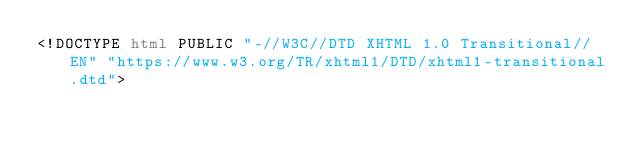Convert code to text. <code><loc_0><loc_0><loc_500><loc_500><_HTML_><!DOCTYPE html PUBLIC "-//W3C//DTD XHTML 1.0 Transitional//EN" "https://www.w3.org/TR/xhtml1/DTD/xhtml1-transitional.dtd"></code> 